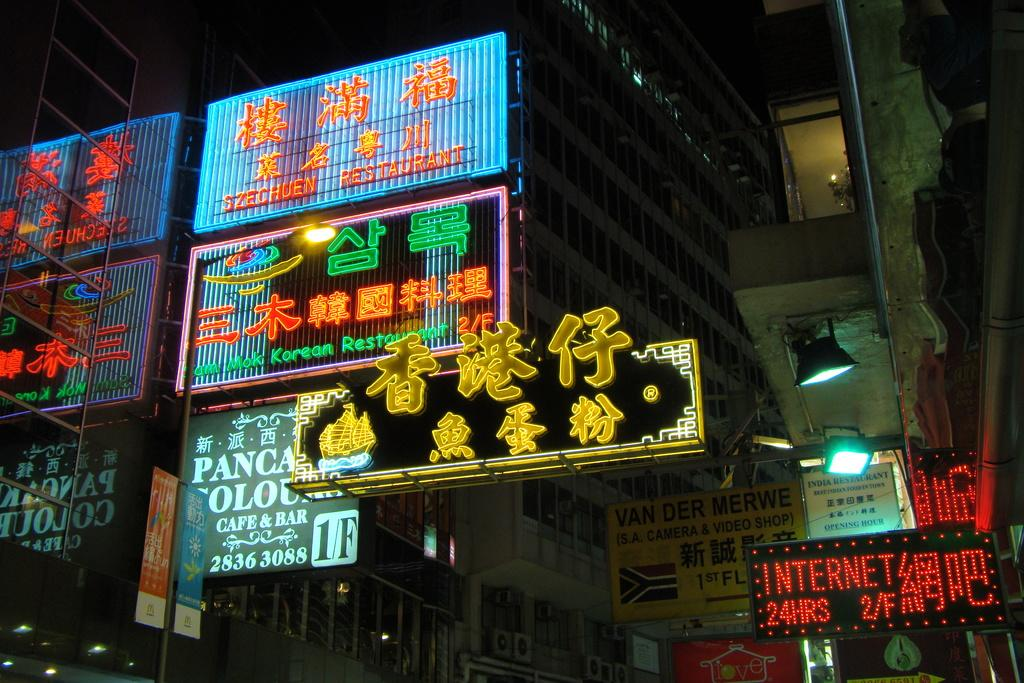What type of structures can be seen in the image? There are buildings in the image. What additional features are present on the buildings? There are lighted boards in the image. Can you describe the lighting conditions in the image? There are lights visible in the image. How does the building react to the sound of a bell in the image? There is no bell present in the image, and therefore no reaction can be observed. 